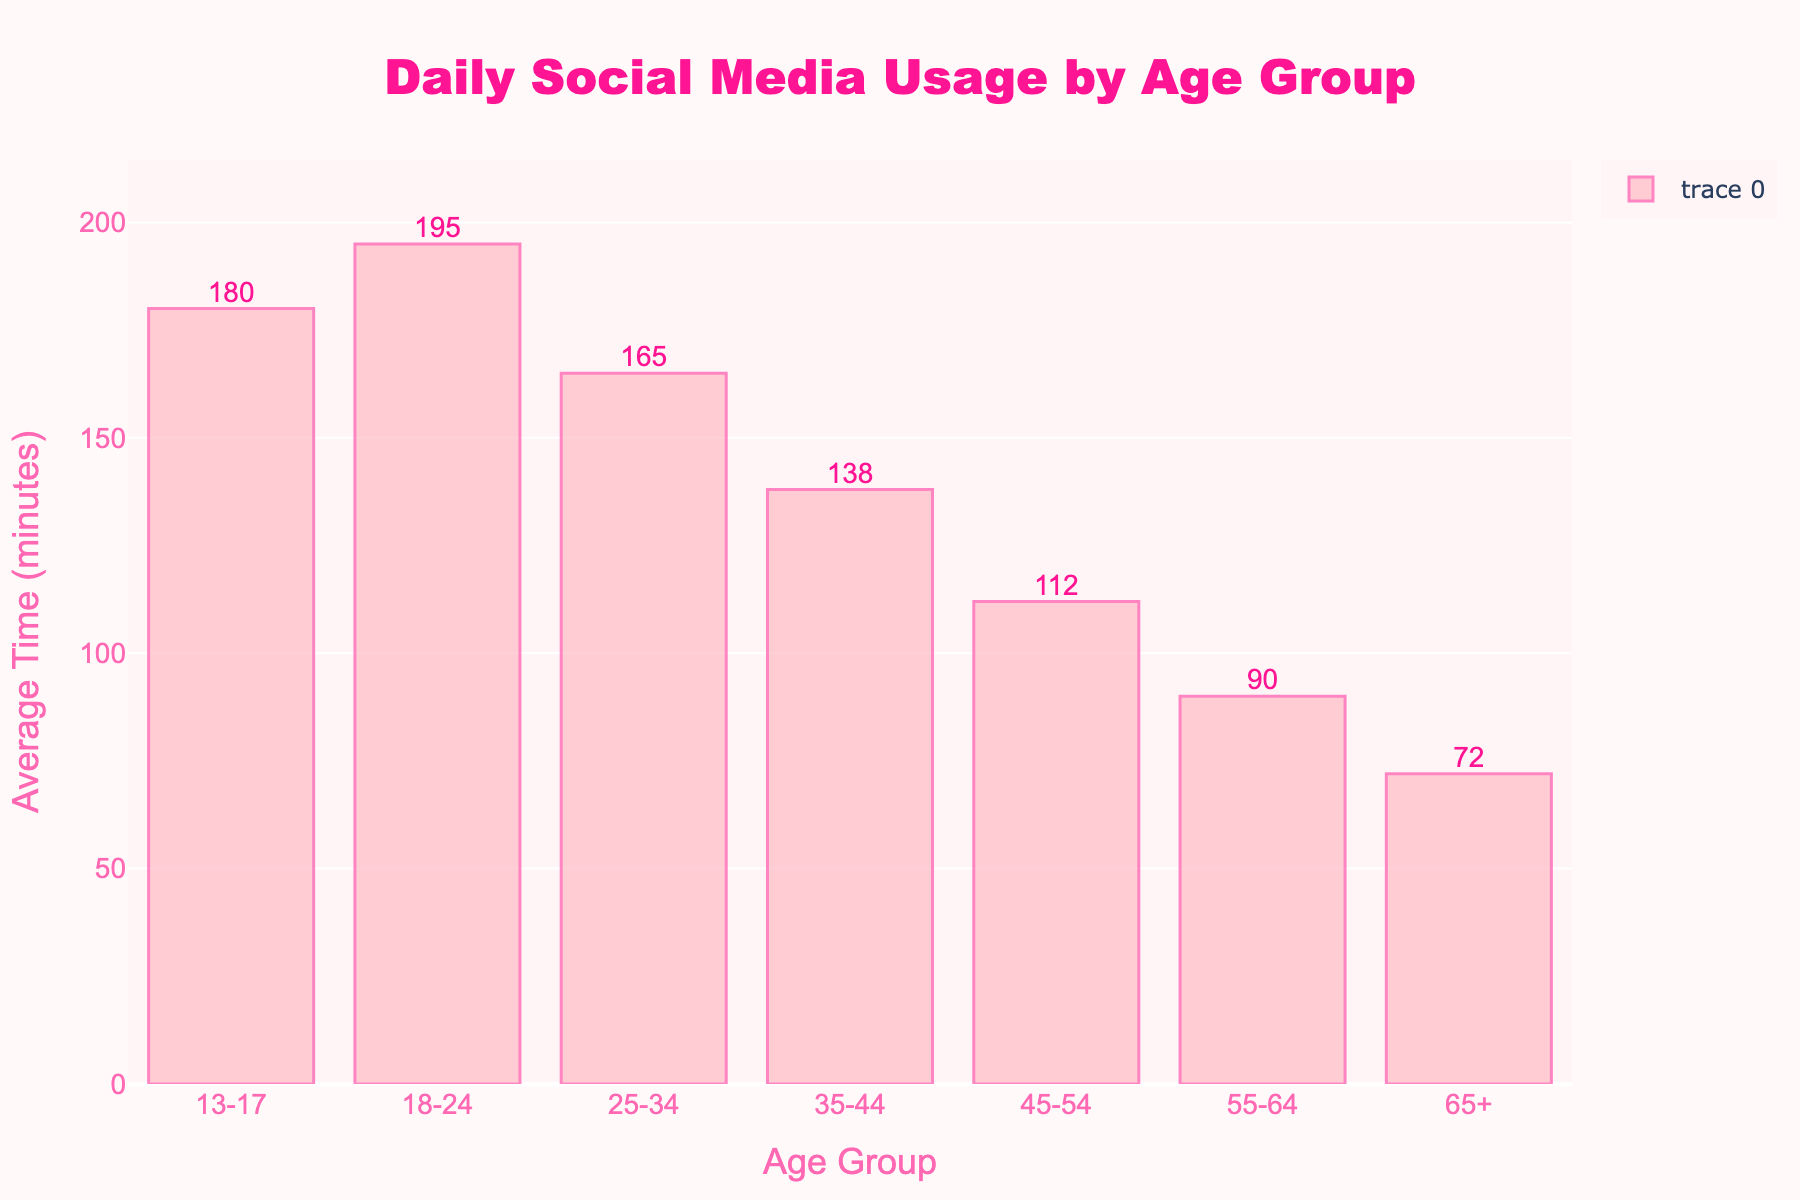Which age group spends the most time on social media daily? The tallest bar corresponds to the 18-24 age group, indicating they spend the most time.
Answer: 18-24 How much more time do 18-24-year-olds spend on social media daily compared to 65+? The 18-24 age group spends 195 minutes, and the 65+ age group spends 72 minutes. The difference is 195 - 72.
Answer: 123 minutes Which age group has the shortest daily social media usage? The shortest bar represents the age group of 65+, indicating they spend the least time.
Answer: 65+ What is the average daily social media usage of the age groups from 35 to 64? The 35-44, 45-54, and 55-64 age groups have usage times of 138, 112, and 90 minutes, respectively. The average is (138 + 112 + 90)/3.
Answer: 113.3 minutes How does the daily social media usage of 25-34-year-olds compare to 45-54-year-olds? The 25-34 age group spends 165 minutes, while the 45-54 age group spends 112 minutes. The 25-34 age group spends more time.
Answer: 25-34 spends more What is the total daily social media usage of all age groups combined? Sum all the average daily times: 180 + 195 + 165 + 138 + 112 + 90 + 72.
Answer: 952 minutes Compare the social media usage between 13-17 and 55-64 age groups. Who spends more time, and by how much? 13-17 age group spends 180 minutes, and 55-64 spends 90 minutes. The difference is 180 - 90.
Answer: 13-17 spends 90 more minutes Are there any age groups that spend an equal amount of time on social media daily? By inspecting the height of the bars, none of the bars are of equal height, indicating no groups spend the same time.
Answer: No What is the second highest average daily time spent on social media and which age group does it pertain to? The second tallest bar corresponds to the 13-17 age group with an average of 180 minutes.
Answer: 180 minutes What's the difference in social media usage between the age groups 25-34 and 35-44? The 25-34 age group spends 165 minutes, and the 35-44 age group spends 138 minutes. The difference is 165 - 138.
Answer: 27 minutes 